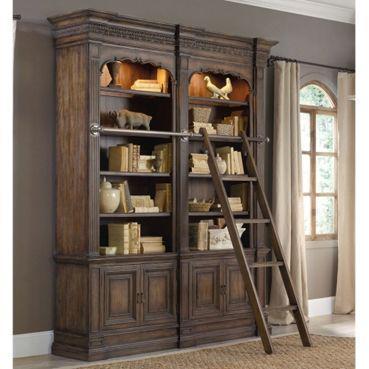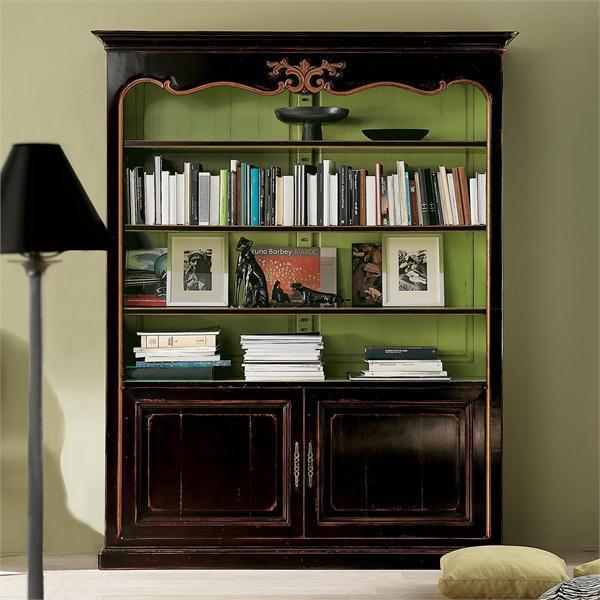The first image is the image on the left, the second image is the image on the right. Evaluate the accuracy of this statement regarding the images: "One large shelf unit is shown with an optional ladder accessory.". Is it true? Answer yes or no. Yes. 